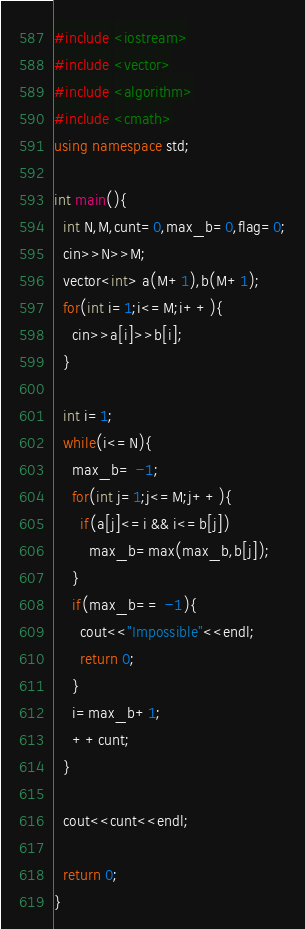<code> <loc_0><loc_0><loc_500><loc_500><_C++_>#include <iostream>
#include <vector>
#include <algorithm>
#include <cmath>
using namespace std;

int main(){
  int N,M,cunt=0,max_b=0,flag=0;
  cin>>N>>M;
  vector<int> a(M+1),b(M+1);
  for(int i=1;i<=M;i++){
    cin>>a[i]>>b[i];
  }

  int i=1;
  while(i<=N){
    max_b= -1;
    for(int j=1;j<=M;j++){
      if(a[j]<=i && i<=b[j])
        max_b=max(max_b,b[j]);
    }
    if(max_b== -1){
      cout<<"Impossible"<<endl;
      return 0;
    }
    i=max_b+1;
    ++cunt;
  }

  cout<<cunt<<endl;

  return 0;
}
</code> 